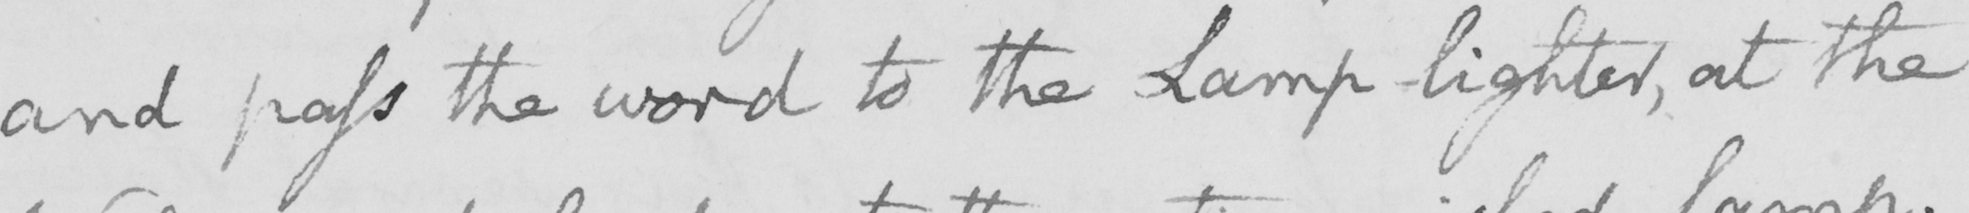Can you read and transcribe this handwriting? and pass the word to the Lamp-lighter , at the 